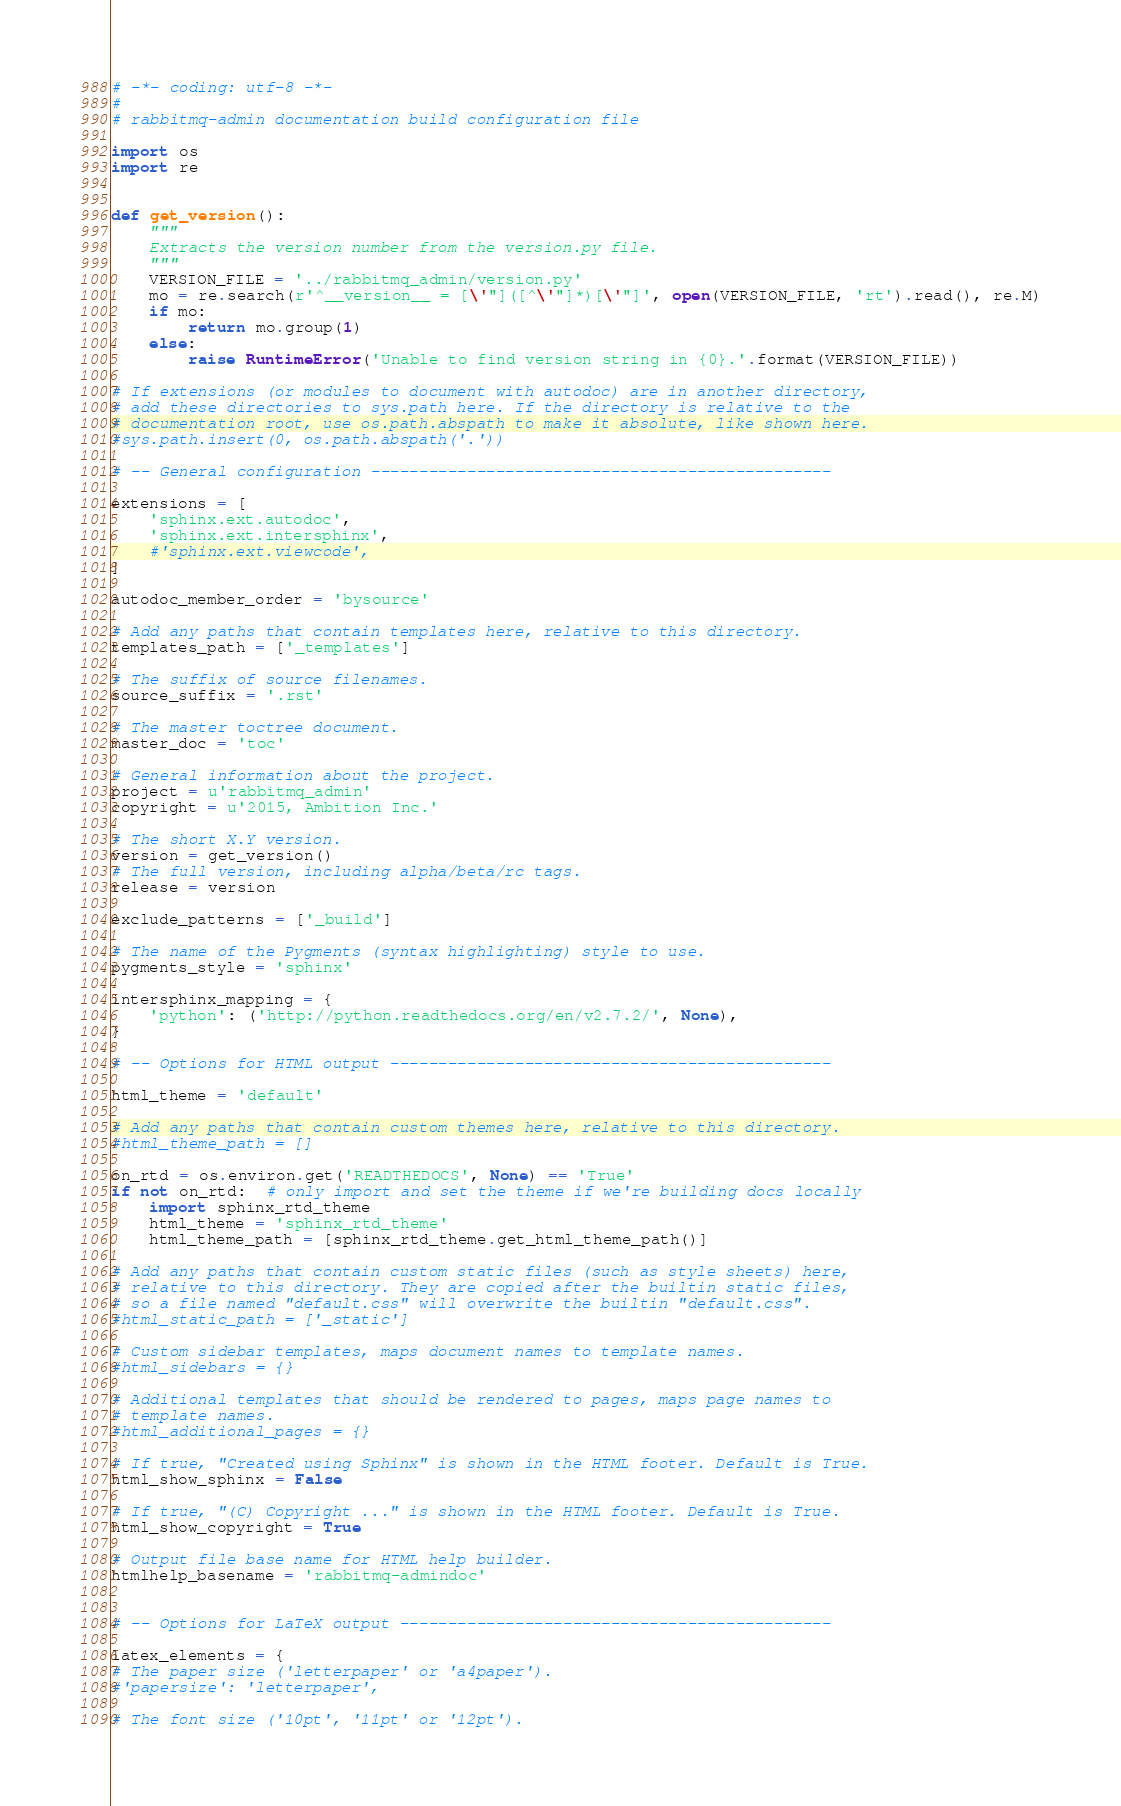Convert code to text. <code><loc_0><loc_0><loc_500><loc_500><_Python_># -*- coding: utf-8 -*-
#
# rabbitmq-admin documentation build configuration file

import os
import re


def get_version():
    """
    Extracts the version number from the version.py file.
    """
    VERSION_FILE = '../rabbitmq_admin/version.py'
    mo = re.search(r'^__version__ = [\'"]([^\'"]*)[\'"]', open(VERSION_FILE, 'rt').read(), re.M)
    if mo:
        return mo.group(1)
    else:
        raise RuntimeError('Unable to find version string in {0}.'.format(VERSION_FILE))

# If extensions (or modules to document with autodoc) are in another directory,
# add these directories to sys.path here. If the directory is relative to the
# documentation root, use os.path.abspath to make it absolute, like shown here.
#sys.path.insert(0, os.path.abspath('.'))

# -- General configuration ------------------------------------------------

extensions = [
    'sphinx.ext.autodoc',
    'sphinx.ext.intersphinx',
    #'sphinx.ext.viewcode',
]

autodoc_member_order = 'bysource'

# Add any paths that contain templates here, relative to this directory.
templates_path = ['_templates']

# The suffix of source filenames.
source_suffix = '.rst'

# The master toctree document.
master_doc = 'toc'

# General information about the project.
project = u'rabbitmq_admin'
copyright = u'2015, Ambition Inc.'

# The short X.Y version.
version = get_version()
# The full version, including alpha/beta/rc tags.
release = version

exclude_patterns = ['_build']

# The name of the Pygments (syntax highlighting) style to use.
pygments_style = 'sphinx'

intersphinx_mapping = {
    'python': ('http://python.readthedocs.org/en/v2.7.2/', None),
}

# -- Options for HTML output ----------------------------------------------

html_theme = 'default'

# Add any paths that contain custom themes here, relative to this directory.
#html_theme_path = []

on_rtd = os.environ.get('READTHEDOCS', None) == 'True'
if not on_rtd:  # only import and set the theme if we're building docs locally
    import sphinx_rtd_theme
    html_theme = 'sphinx_rtd_theme'
    html_theme_path = [sphinx_rtd_theme.get_html_theme_path()]

# Add any paths that contain custom static files (such as style sheets) here,
# relative to this directory. They are copied after the builtin static files,
# so a file named "default.css" will overwrite the builtin "default.css".
#html_static_path = ['_static']

# Custom sidebar templates, maps document names to template names.
#html_sidebars = {}

# Additional templates that should be rendered to pages, maps page names to
# template names.
#html_additional_pages = {}

# If true, "Created using Sphinx" is shown in the HTML footer. Default is True.
html_show_sphinx = False

# If true, "(C) Copyright ..." is shown in the HTML footer. Default is True.
html_show_copyright = True

# Output file base name for HTML help builder.
htmlhelp_basename = 'rabbitmq-admindoc'


# -- Options for LaTeX output ---------------------------------------------

latex_elements = {
# The paper size ('letterpaper' or 'a4paper').
#'papersize': 'letterpaper',

# The font size ('10pt', '11pt' or '12pt').</code> 